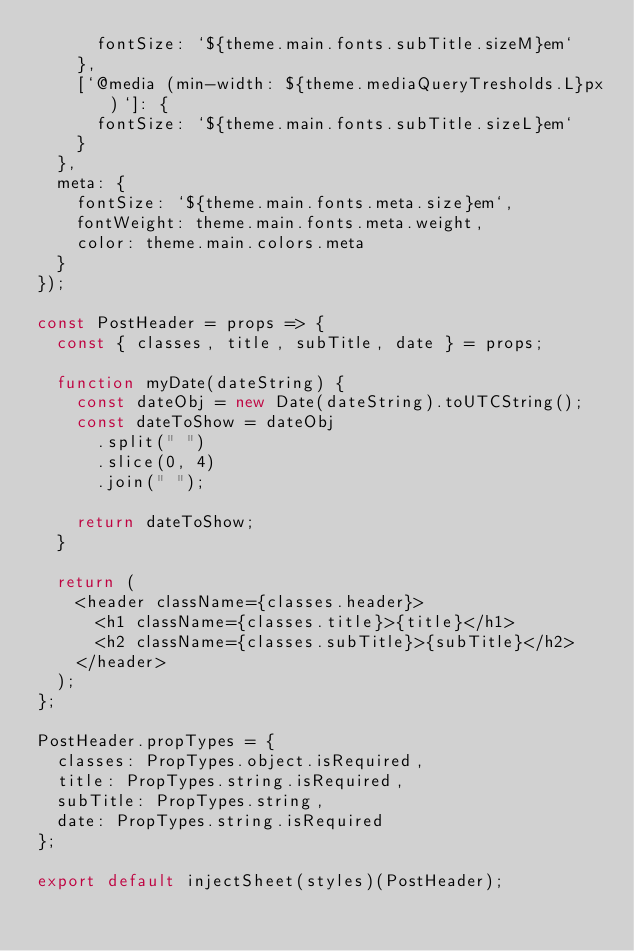Convert code to text. <code><loc_0><loc_0><loc_500><loc_500><_JavaScript_>      fontSize: `${theme.main.fonts.subTitle.sizeM}em`
    },
    [`@media (min-width: ${theme.mediaQueryTresholds.L}px)`]: {
      fontSize: `${theme.main.fonts.subTitle.sizeL}em`
    }
  },
  meta: {
    fontSize: `${theme.main.fonts.meta.size}em`,
    fontWeight: theme.main.fonts.meta.weight,
    color: theme.main.colors.meta
  }
});

const PostHeader = props => {
  const { classes, title, subTitle, date } = props;

  function myDate(dateString) {
    const dateObj = new Date(dateString).toUTCString();
    const dateToShow = dateObj
      .split(" ")
      .slice(0, 4)
      .join(" ");

    return dateToShow;
  }

  return (
    <header className={classes.header}>
      <h1 className={classes.title}>{title}</h1>
      <h2 className={classes.subTitle}>{subTitle}</h2>
    </header>
  );
};

PostHeader.propTypes = {
  classes: PropTypes.object.isRequired,
  title: PropTypes.string.isRequired,
  subTitle: PropTypes.string,
  date: PropTypes.string.isRequired
};

export default injectSheet(styles)(PostHeader);
</code> 